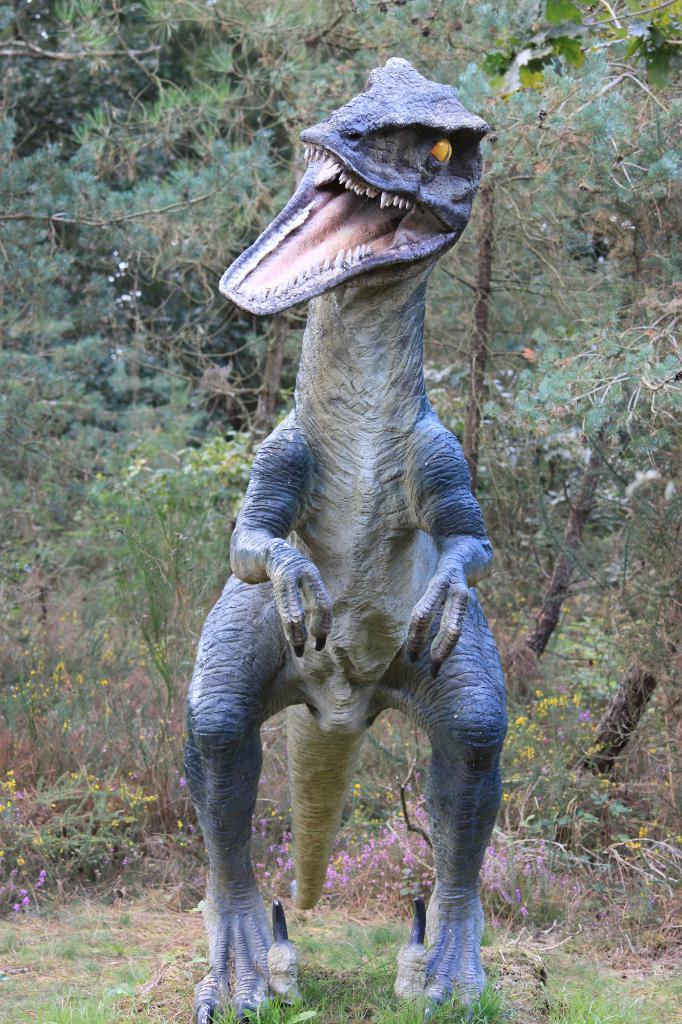What is the main subject in the image? There is a sculpture in the image. What type of natural environment is visible in the image? There is grass visible in the image. What other living organisms can be seen in the image? There are plants in the image. How many fingers can be seen on the pig in the image? There is no pig present in the image, and therefore no fingers can be observed. 